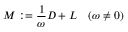Convert formula to latex. <formula><loc_0><loc_0><loc_500><loc_500>M \colon = { \frac { 1 } { \omega } } D + L \quad ( \omega \neq 0 )</formula> 